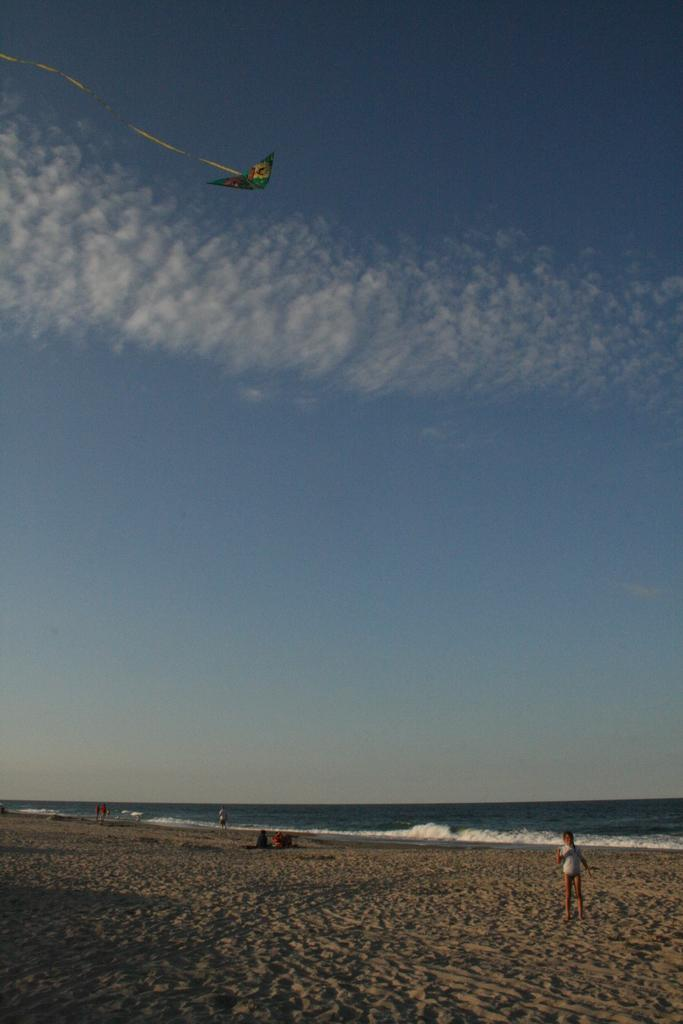What is the child standing on in the image? The child is standing on the sand surface of a ground. What can be seen in the background of the image? There are persons in the background and tides of an ocean in the background. What is flying in the air in the image? There is a kite in the air. What is the color of the sky in the image? The sky is blue with clouds in the image. Can you tell me how the child is using paste in the image? There is no mention of paste in the image, so it cannot be determined how the child might be using it. 